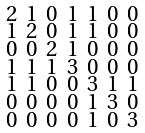Convert formula to latex. <formula><loc_0><loc_0><loc_500><loc_500>\begin{smallmatrix} 2 & 1 & 0 & 1 & 1 & 0 & 0 \\ 1 & 2 & 0 & 1 & 1 & 0 & 0 \\ 0 & 0 & 2 & 1 & 0 & 0 & 0 \\ 1 & 1 & 1 & 3 & 0 & 0 & 0 \\ 1 & 1 & 0 & 0 & 3 & 1 & 1 \\ 0 & 0 & 0 & 0 & 1 & 3 & 0 \\ 0 & 0 & 0 & 0 & 1 & 0 & 3 \end{smallmatrix}</formula> 